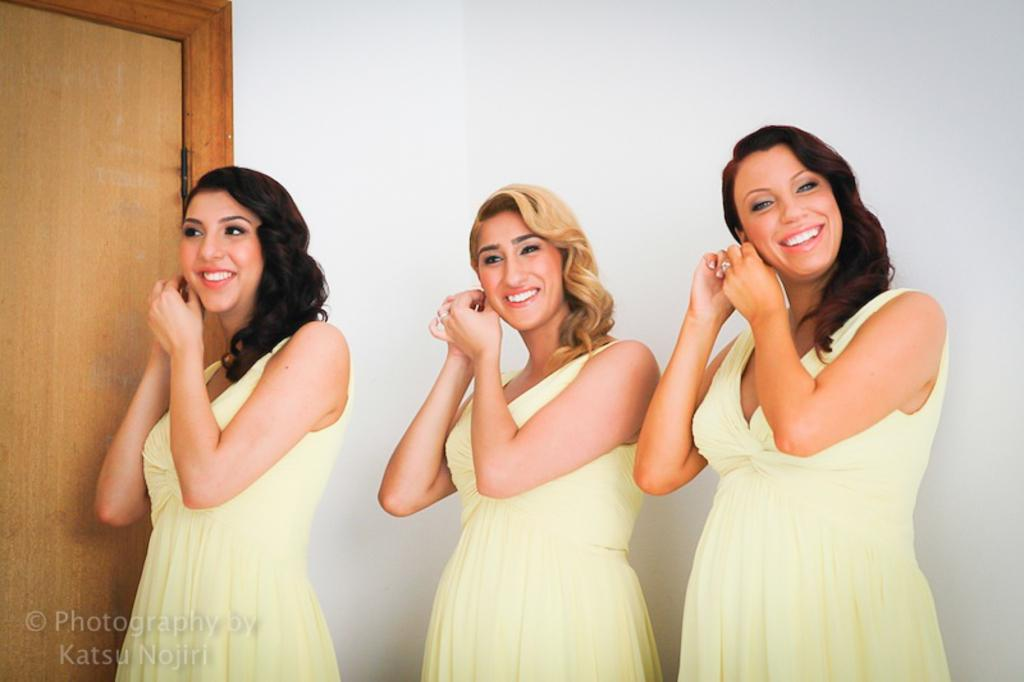How many people are in the image? There are three ladies in the image. What are the ladies doing in the image? The ladies are standing and smiling. What can be seen in the background of the image? There is a door and a wall in the background of the image. Is there any text present in the image? Yes, there is some text at the bottom of the image. What type of fruit is the lady in the middle holding in the image? There is no fruit present in the image; the ladies are not holding any fruit. Is there a hat visible on any of the ladies in the image? No, there are no hats visible on any of the ladies in the image. 